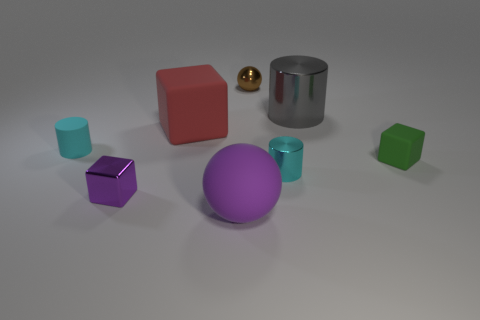Add 1 cyan cylinders. How many objects exist? 9 Subtract all cubes. How many objects are left? 5 Subtract all big yellow objects. Subtract all tiny brown spheres. How many objects are left? 7 Add 8 small green blocks. How many small green blocks are left? 9 Add 3 large red matte cubes. How many large red matte cubes exist? 4 Subtract 0 red cylinders. How many objects are left? 8 